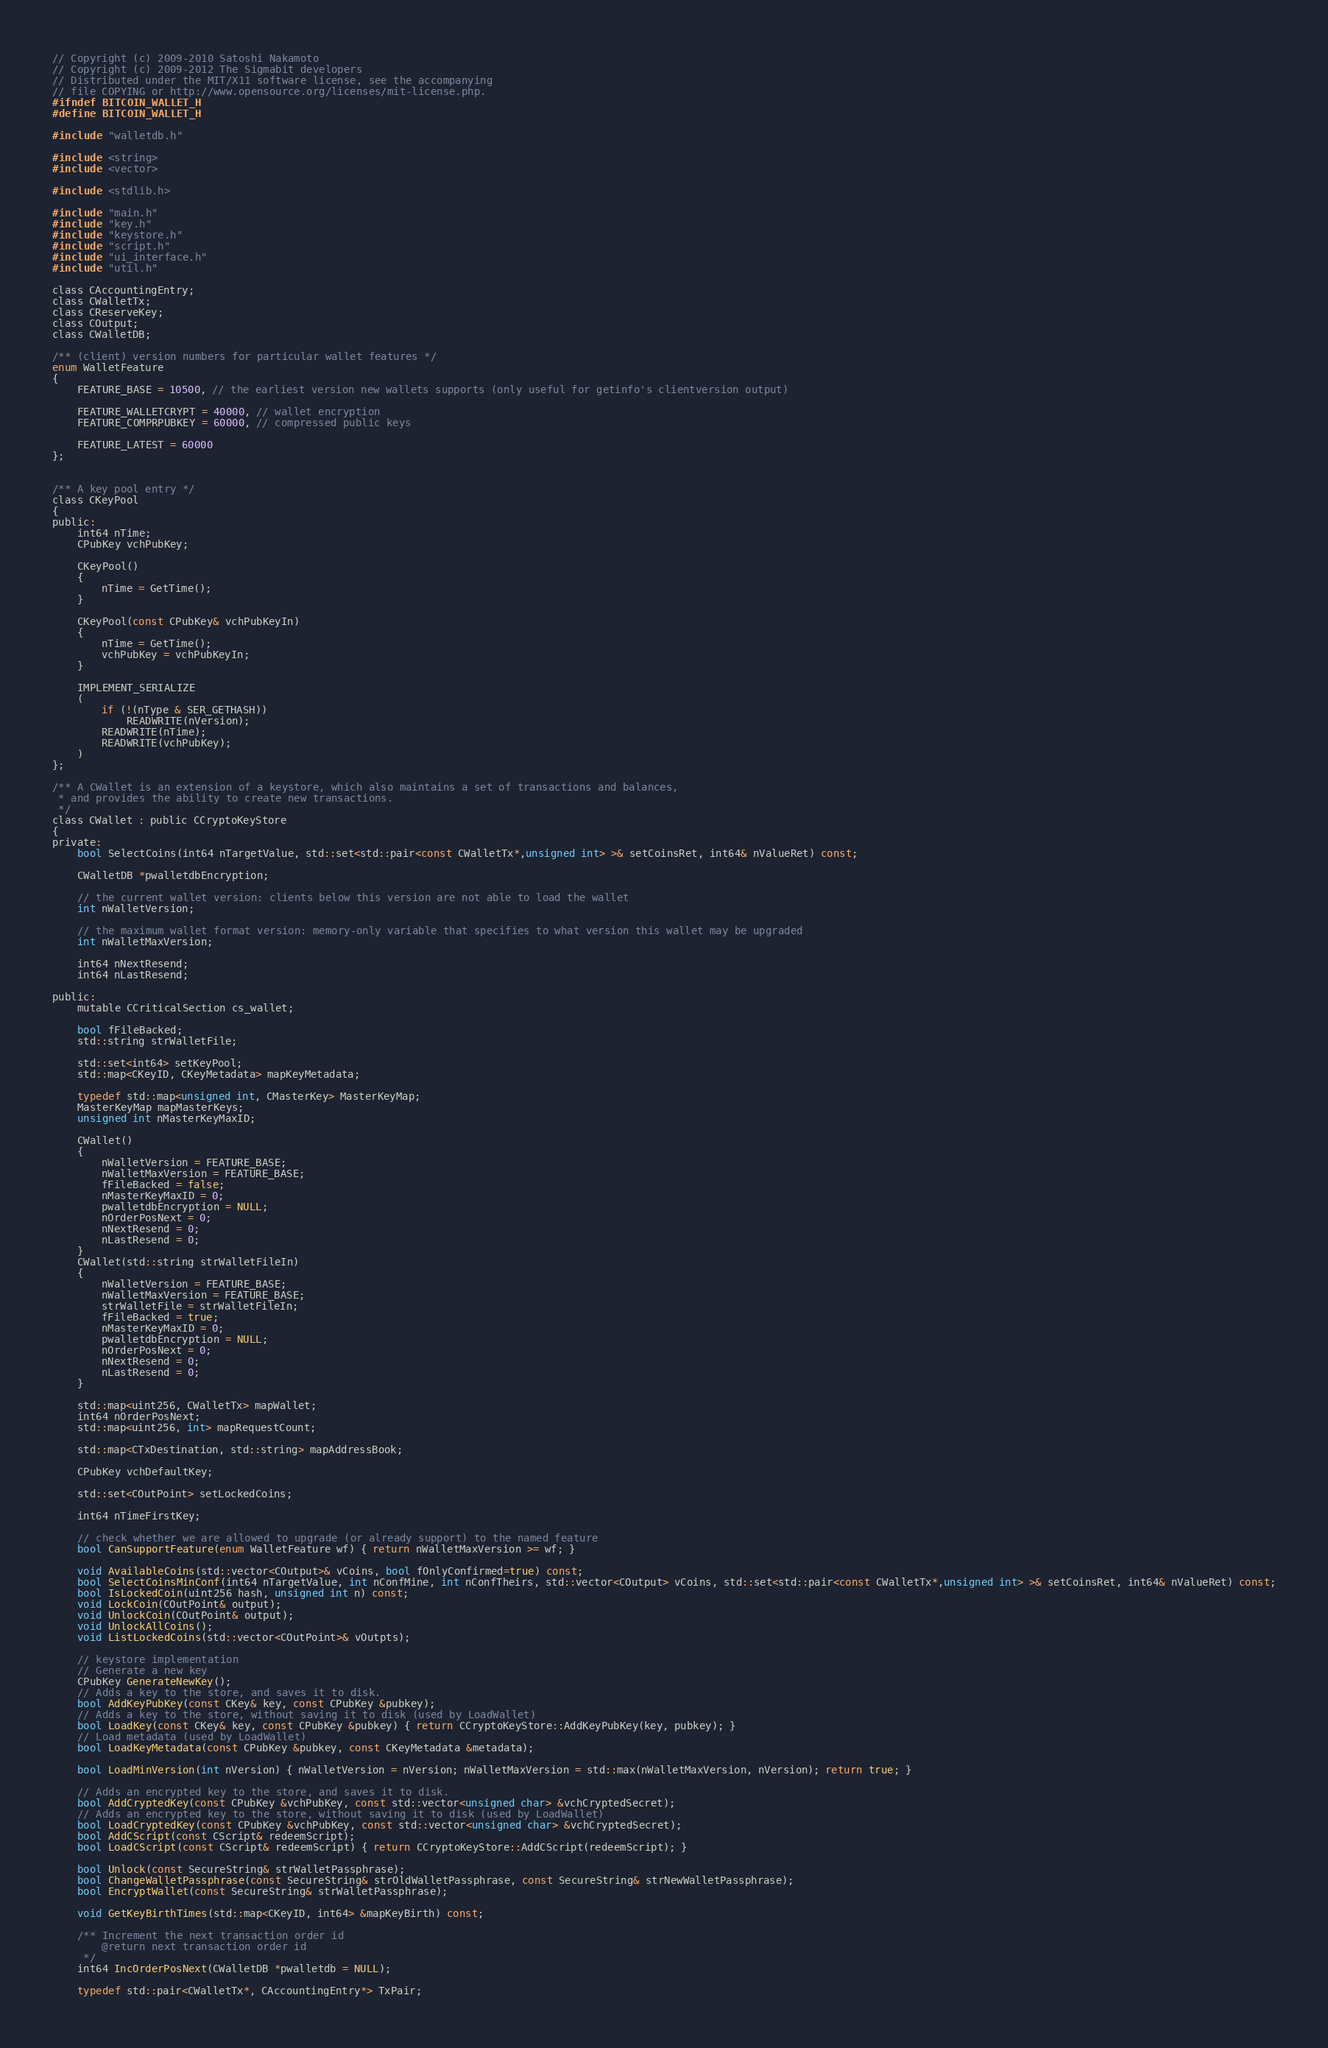<code> <loc_0><loc_0><loc_500><loc_500><_C_>// Copyright (c) 2009-2010 Satoshi Nakamoto
// Copyright (c) 2009-2012 The Sigmabit developers
// Distributed under the MIT/X11 software license, see the accompanying
// file COPYING or http://www.opensource.org/licenses/mit-license.php.
#ifndef BITCOIN_WALLET_H
#define BITCOIN_WALLET_H

#include "walletdb.h"

#include <string>
#include <vector>

#include <stdlib.h>

#include "main.h"
#include "key.h"
#include "keystore.h"
#include "script.h"
#include "ui_interface.h"
#include "util.h"

class CAccountingEntry;
class CWalletTx;
class CReserveKey;
class COutput;
class CWalletDB;

/** (client) version numbers for particular wallet features */
enum WalletFeature
{
    FEATURE_BASE = 10500, // the earliest version new wallets supports (only useful for getinfo's clientversion output)

    FEATURE_WALLETCRYPT = 40000, // wallet encryption
    FEATURE_COMPRPUBKEY = 60000, // compressed public keys

    FEATURE_LATEST = 60000
};


/** A key pool entry */
class CKeyPool
{
public:
    int64 nTime;
    CPubKey vchPubKey;

    CKeyPool()
    {
        nTime = GetTime();
    }

    CKeyPool(const CPubKey& vchPubKeyIn)
    {
        nTime = GetTime();
        vchPubKey = vchPubKeyIn;
    }

    IMPLEMENT_SERIALIZE
    (
        if (!(nType & SER_GETHASH))
            READWRITE(nVersion);
        READWRITE(nTime);
        READWRITE(vchPubKey);
    )
};

/** A CWallet is an extension of a keystore, which also maintains a set of transactions and balances,
 * and provides the ability to create new transactions.
 */
class CWallet : public CCryptoKeyStore
{
private:
    bool SelectCoins(int64 nTargetValue, std::set<std::pair<const CWalletTx*,unsigned int> >& setCoinsRet, int64& nValueRet) const;

    CWalletDB *pwalletdbEncryption;

    // the current wallet version: clients below this version are not able to load the wallet
    int nWalletVersion;

    // the maximum wallet format version: memory-only variable that specifies to what version this wallet may be upgraded
    int nWalletMaxVersion;

    int64 nNextResend;
    int64 nLastResend;

public:
    mutable CCriticalSection cs_wallet;

    bool fFileBacked;
    std::string strWalletFile;

    std::set<int64> setKeyPool;
    std::map<CKeyID, CKeyMetadata> mapKeyMetadata;

    typedef std::map<unsigned int, CMasterKey> MasterKeyMap;
    MasterKeyMap mapMasterKeys;
    unsigned int nMasterKeyMaxID;

    CWallet()
    {
        nWalletVersion = FEATURE_BASE;
        nWalletMaxVersion = FEATURE_BASE;
        fFileBacked = false;
        nMasterKeyMaxID = 0;
        pwalletdbEncryption = NULL;
        nOrderPosNext = 0;
        nNextResend = 0;
        nLastResend = 0;
    }
    CWallet(std::string strWalletFileIn)
    {
        nWalletVersion = FEATURE_BASE;
        nWalletMaxVersion = FEATURE_BASE;
        strWalletFile = strWalletFileIn;
        fFileBacked = true;
        nMasterKeyMaxID = 0;
        pwalletdbEncryption = NULL;
        nOrderPosNext = 0;
        nNextResend = 0;
        nLastResend = 0;
    }

    std::map<uint256, CWalletTx> mapWallet;
    int64 nOrderPosNext;
    std::map<uint256, int> mapRequestCount;

    std::map<CTxDestination, std::string> mapAddressBook;

    CPubKey vchDefaultKey;

    std::set<COutPoint> setLockedCoins;

    int64 nTimeFirstKey;

    // check whether we are allowed to upgrade (or already support) to the named feature
    bool CanSupportFeature(enum WalletFeature wf) { return nWalletMaxVersion >= wf; }

    void AvailableCoins(std::vector<COutput>& vCoins, bool fOnlyConfirmed=true) const;
    bool SelectCoinsMinConf(int64 nTargetValue, int nConfMine, int nConfTheirs, std::vector<COutput> vCoins, std::set<std::pair<const CWalletTx*,unsigned int> >& setCoinsRet, int64& nValueRet) const;
    bool IsLockedCoin(uint256 hash, unsigned int n) const;
    void LockCoin(COutPoint& output);
    void UnlockCoin(COutPoint& output);
    void UnlockAllCoins();
    void ListLockedCoins(std::vector<COutPoint>& vOutpts);

    // keystore implementation
    // Generate a new key
    CPubKey GenerateNewKey();
    // Adds a key to the store, and saves it to disk.
    bool AddKeyPubKey(const CKey& key, const CPubKey &pubkey);
    // Adds a key to the store, without saving it to disk (used by LoadWallet)
    bool LoadKey(const CKey& key, const CPubKey &pubkey) { return CCryptoKeyStore::AddKeyPubKey(key, pubkey); }
    // Load metadata (used by LoadWallet)
    bool LoadKeyMetadata(const CPubKey &pubkey, const CKeyMetadata &metadata);

    bool LoadMinVersion(int nVersion) { nWalletVersion = nVersion; nWalletMaxVersion = std::max(nWalletMaxVersion, nVersion); return true; }

    // Adds an encrypted key to the store, and saves it to disk.
    bool AddCryptedKey(const CPubKey &vchPubKey, const std::vector<unsigned char> &vchCryptedSecret);
    // Adds an encrypted key to the store, without saving it to disk (used by LoadWallet)
    bool LoadCryptedKey(const CPubKey &vchPubKey, const std::vector<unsigned char> &vchCryptedSecret);
    bool AddCScript(const CScript& redeemScript);
    bool LoadCScript(const CScript& redeemScript) { return CCryptoKeyStore::AddCScript(redeemScript); }

    bool Unlock(const SecureString& strWalletPassphrase);
    bool ChangeWalletPassphrase(const SecureString& strOldWalletPassphrase, const SecureString& strNewWalletPassphrase);
    bool EncryptWallet(const SecureString& strWalletPassphrase);

    void GetKeyBirthTimes(std::map<CKeyID, int64> &mapKeyBirth) const;

    /** Increment the next transaction order id
        @return next transaction order id
     */
    int64 IncOrderPosNext(CWalletDB *pwalletdb = NULL);

    typedef std::pair<CWalletTx*, CAccountingEntry*> TxPair;</code> 